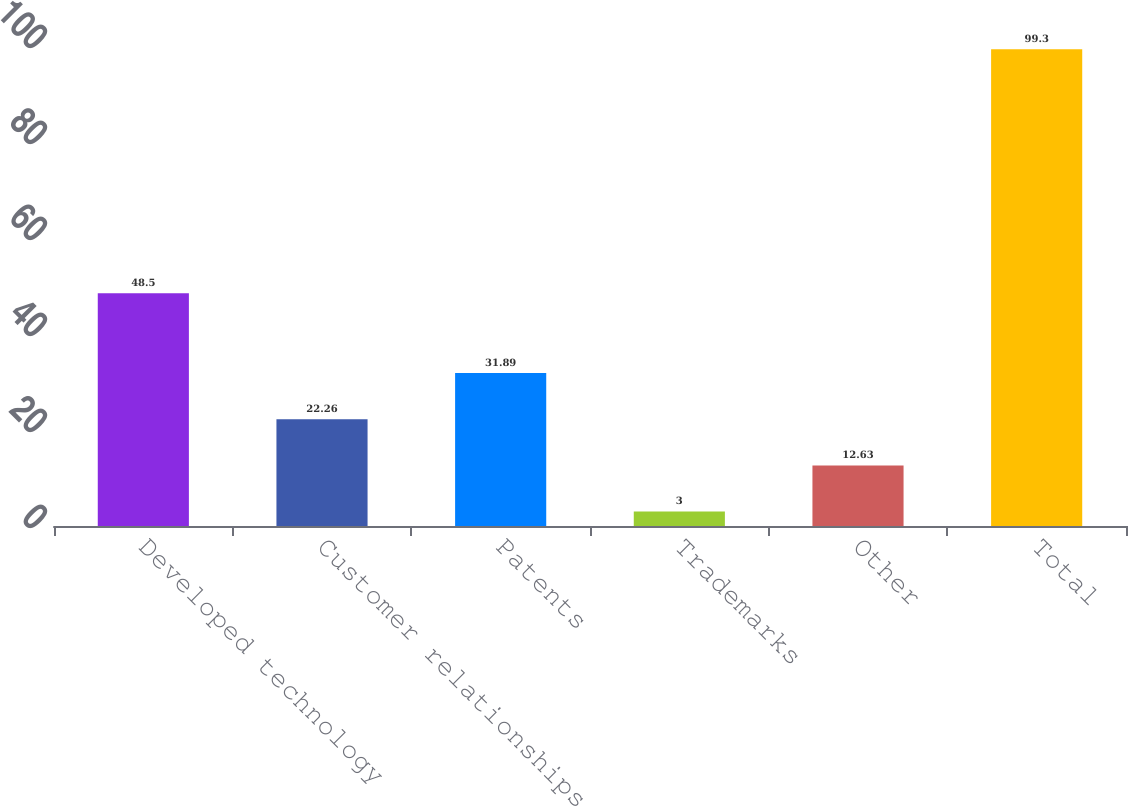Convert chart to OTSL. <chart><loc_0><loc_0><loc_500><loc_500><bar_chart><fcel>Developed technology<fcel>Customer relationships<fcel>Patents<fcel>Trademarks<fcel>Other<fcel>Total<nl><fcel>48.5<fcel>22.26<fcel>31.89<fcel>3<fcel>12.63<fcel>99.3<nl></chart> 